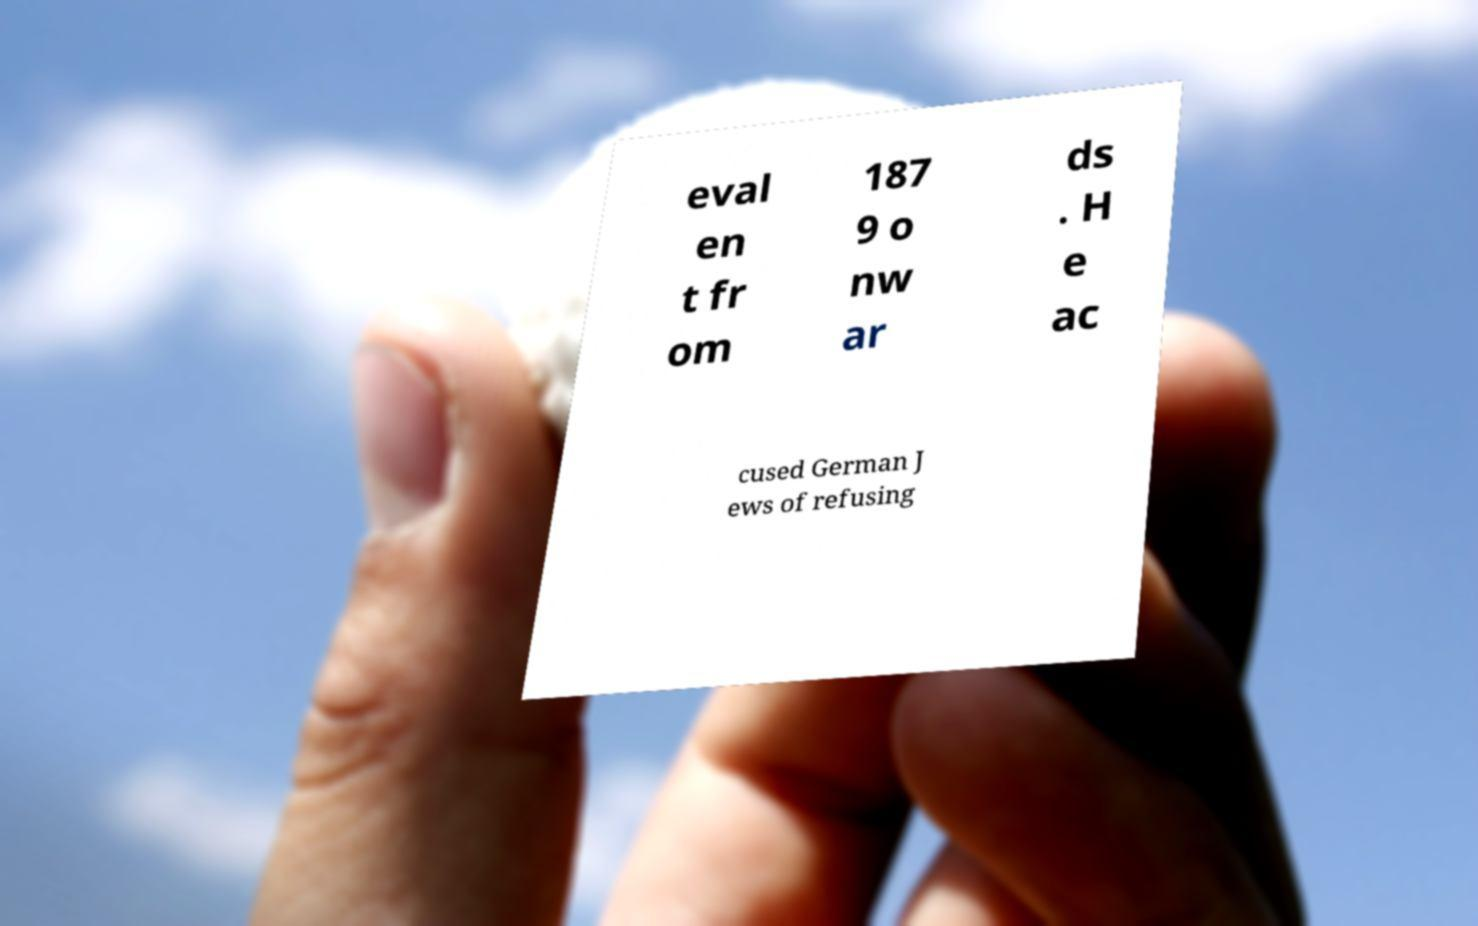For documentation purposes, I need the text within this image transcribed. Could you provide that? eval en t fr om 187 9 o nw ar ds . H e ac cused German J ews of refusing 